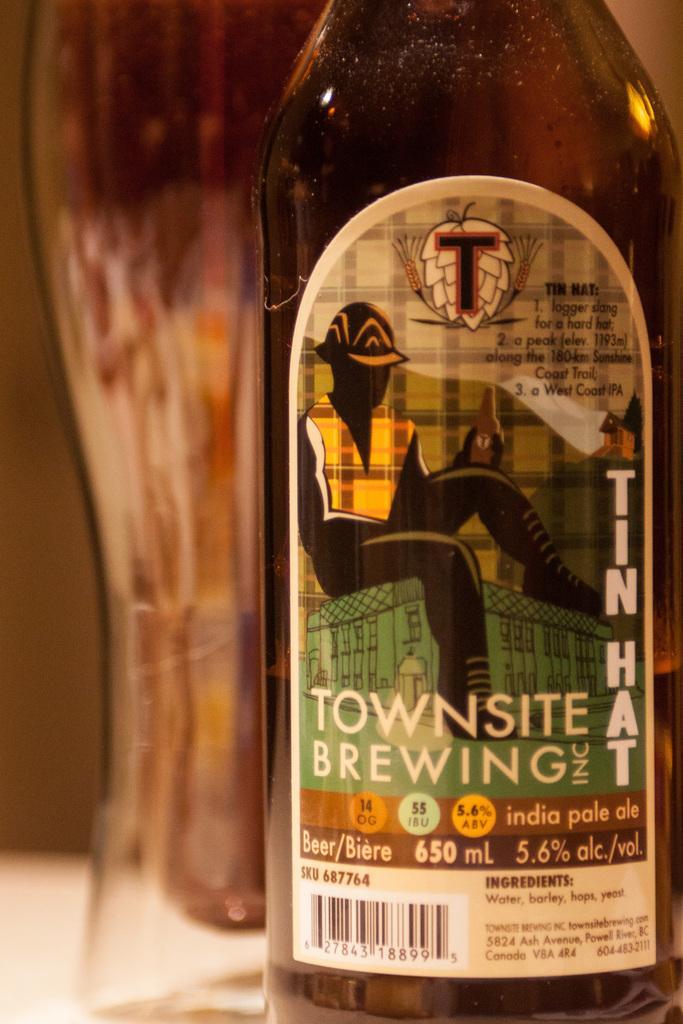Can you describe this image briefly? This is the bottle and this is the label. 